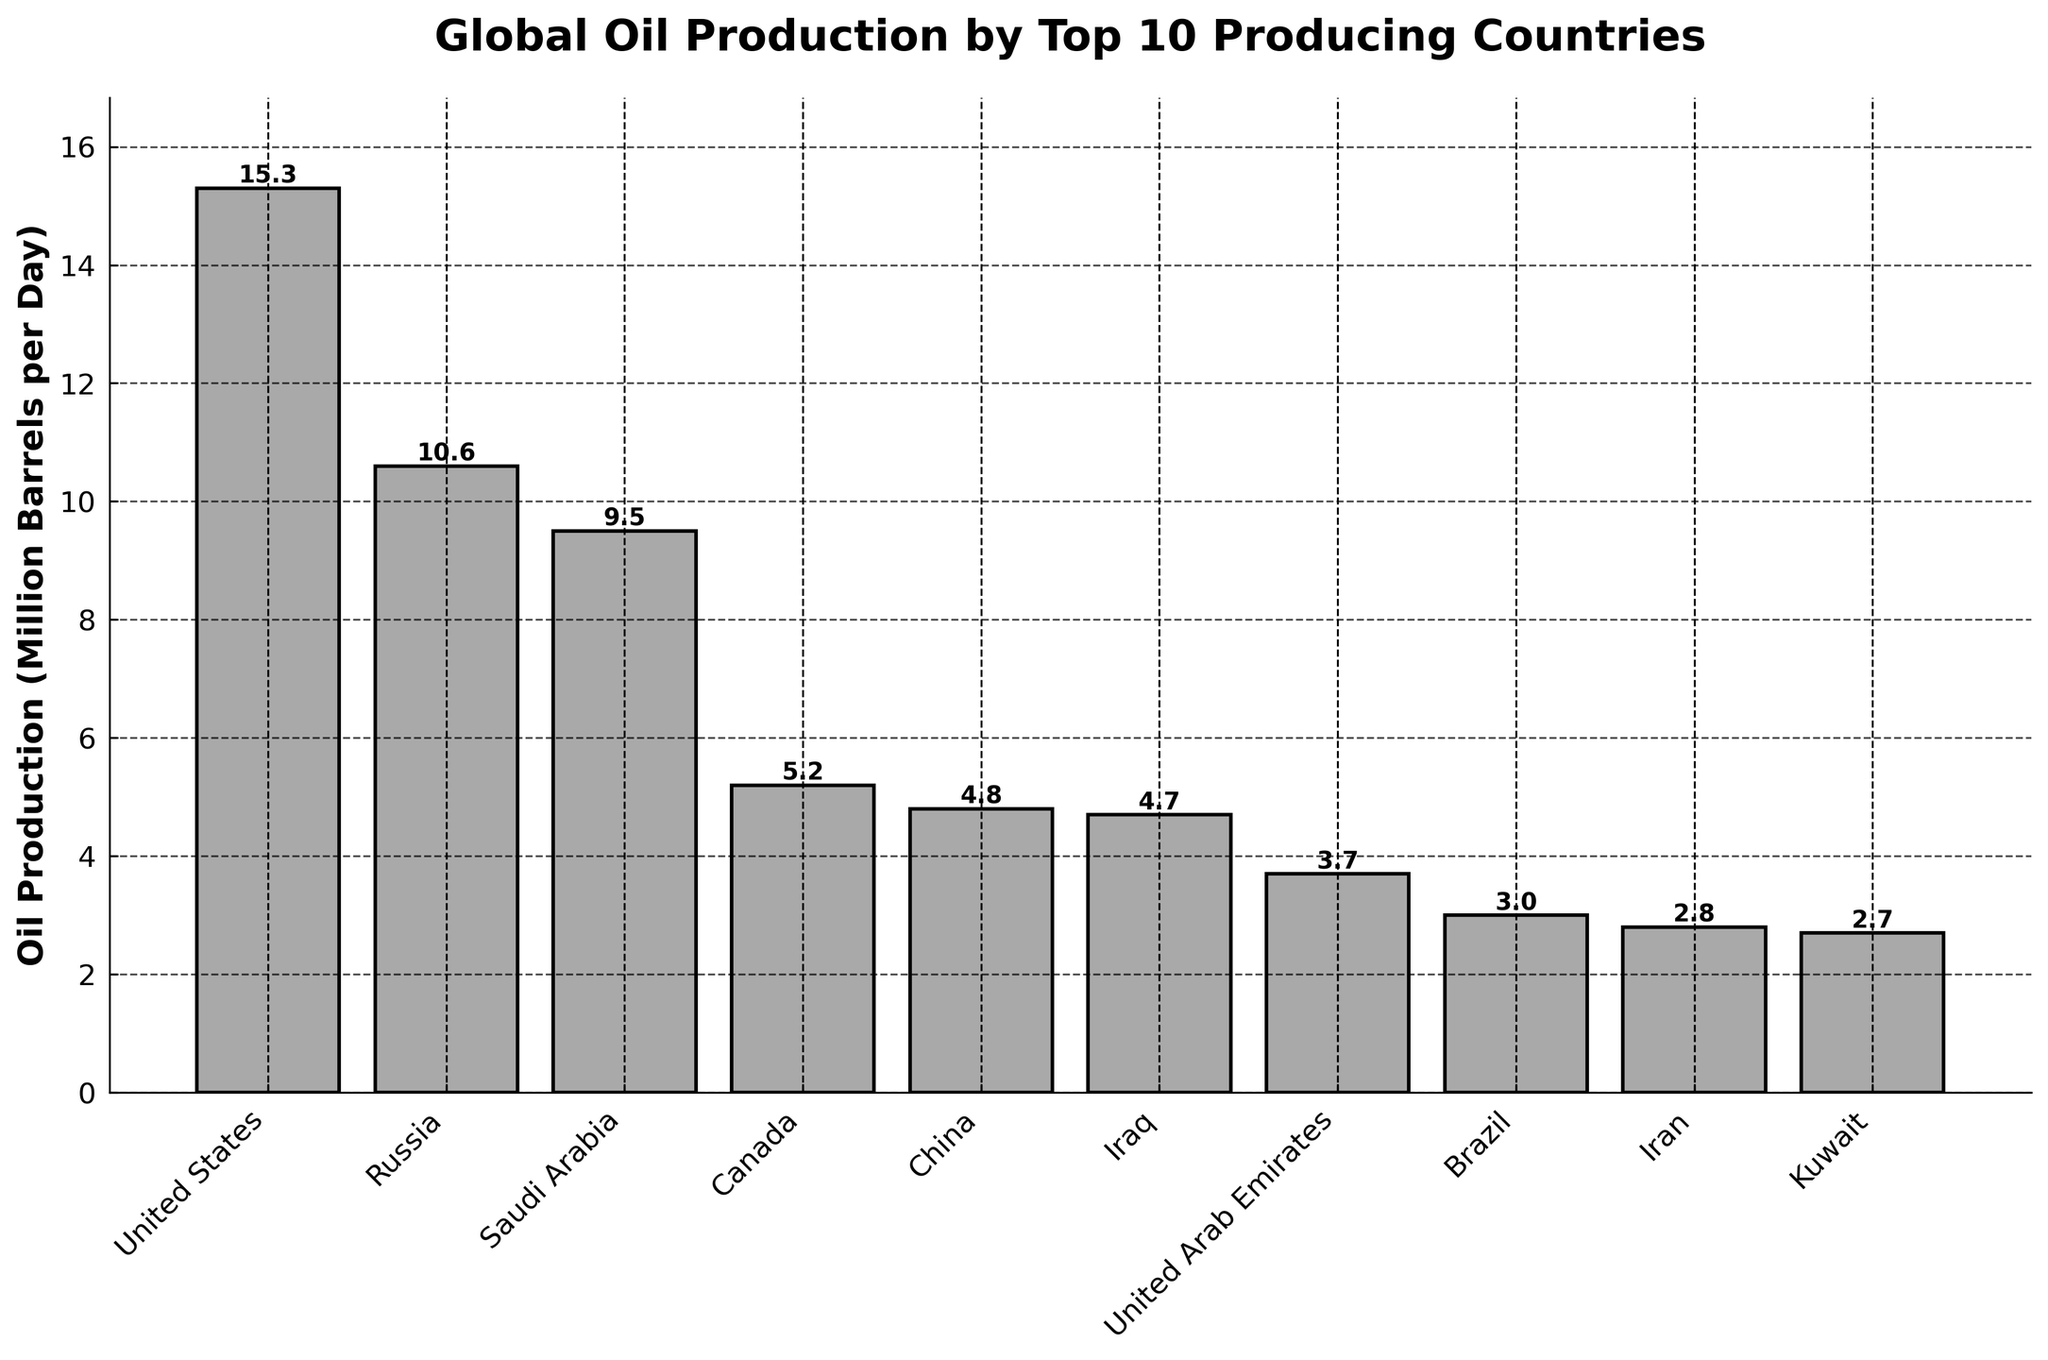Which country has the highest oil production? By looking at the height of the bars, the United States has the highest oil production among the listed countries.
Answer: United States What's the difference in oil production between Russia and Saudi Arabia? According to the bar heights, Russia produces 10.6 million barrels per day, and Saudi Arabia produces 9.5 million barrels per day. The difference is 10.6 - 9.5 = 1.1 million barrels per day.
Answer: 1.1 Arrange Canada, China, and Iraq in descending order of their oil production. By comparing the bar heights, Canada produces 5.2 million barrels per day, China produces 4.8 million barrels per day, and Iraq produces 4.7 million barrels per day. Descending order: Canada, China, Iraq.
Answer: Canada, China, Iraq How much more oil does Kuwait need to produce to match Iraq's production? Kuwait's production is 2.7 million barrels per day, while Iraq's is 4.7 million barrels per day. The difference is 4.7 - 2.7 = 2.0 million barrels per day.
Answer: 2.0 Which country produces the least oil, and how much is it? By inspecting the bar heights, Kuwait produces the least oil at 2.7 million barrels per day.
Answer: Kuwait, 2.7 What is the cumulative oil production of the top three producing countries? Summing up the production of the United States (15.3), Russia (10.6), and Saudi Arabia (9.5), gives 15.3 + 10.6 + 9.5 = 35.4 million barrels per day.
Answer: 35.4 What percentage of the oil production of Brazil is that of the United States? Brazil produces 3.0 million barrels per day, and the United States produces 15.3 million barrels per day. The percentage is (3.0 / 15.3) * 100 ≈ 19.61%.
Answer: ~19.61% Among United Arab Emirates, Brazil, and Iran, which country has the median value of oil production? The oil production values are: UAE (3.7), Brazil (3.0), and Iran (2.8). Sorting them yields 2.8, 3.0, 3.7, with Brazil as the median value.
Answer: Brazil How does the oil production of the United States compare to the combined production of Canada and China? The United States produces 15.3 million barrels per day. Canada and China together produce 5.2 + 4.8 = 10.0 million barrels per day. 15.3 is greater than 10.0.
Answer: Greater On the given chart, which visual attribute is used to differentiate the amount of oil production by each country? The chart uses the height of the bars to represent the amount of oil production by each country.
Answer: Height of the bars 